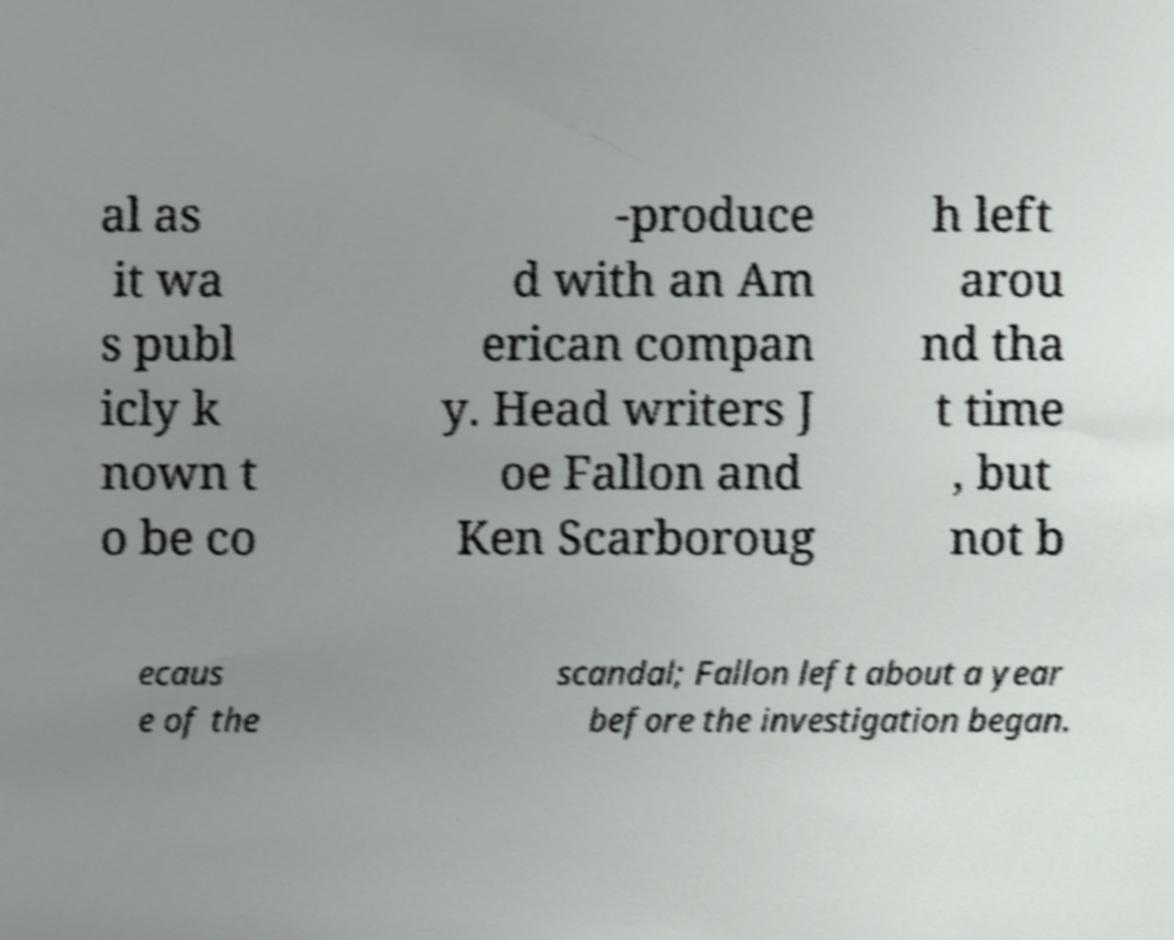What messages or text are displayed in this image? I need them in a readable, typed format. al as it wa s publ icly k nown t o be co -produce d with an Am erican compan y. Head writers J oe Fallon and Ken Scarboroug h left arou nd tha t time , but not b ecaus e of the scandal; Fallon left about a year before the investigation began. 